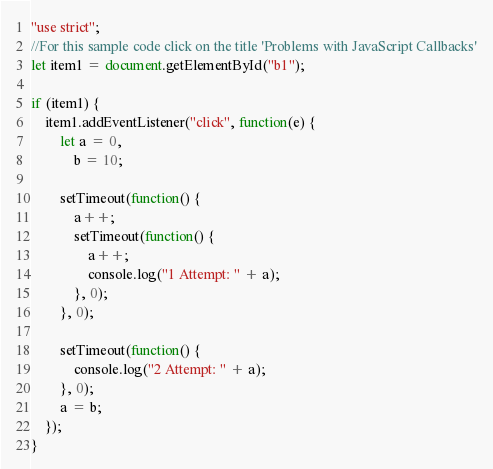<code> <loc_0><loc_0><loc_500><loc_500><_JavaScript_>"use strict";
//For this sample code click on the title 'Problems with JavaScript Callbacks'
let item1 = document.getElementById("b1");

if (item1) {
    item1.addEventListener("click", function(e) {
        let a = 0,
            b = 10;

        setTimeout(function() {
            a++;
            setTimeout(function() {
                a++;
                console.log("1 Attempt: " + a);
            }, 0);
        }, 0);

        setTimeout(function() {
            console.log("2 Attempt: " + a);
        }, 0);
        a = b;
    });
}
</code> 